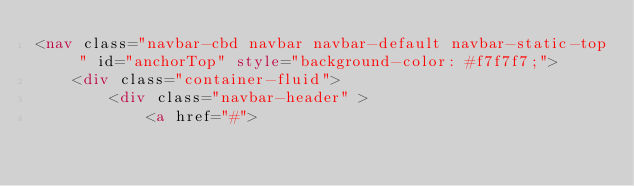<code> <loc_0><loc_0><loc_500><loc_500><_HTML_><nav class="navbar-cbd navbar navbar-default navbar-static-top " id="anchorTop" style="background-color: #f7f7f7;">
    <div class="container-fluid">
        <div class="navbar-header" >
            <a href="#"></code> 